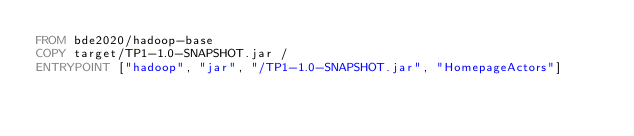<code> <loc_0><loc_0><loc_500><loc_500><_Dockerfile_>FROM bde2020/hadoop-base
COPY target/TP1-1.0-SNAPSHOT.jar /
ENTRYPOINT ["hadoop", "jar", "/TP1-1.0-SNAPSHOT.jar", "HomepageActors"]</code> 